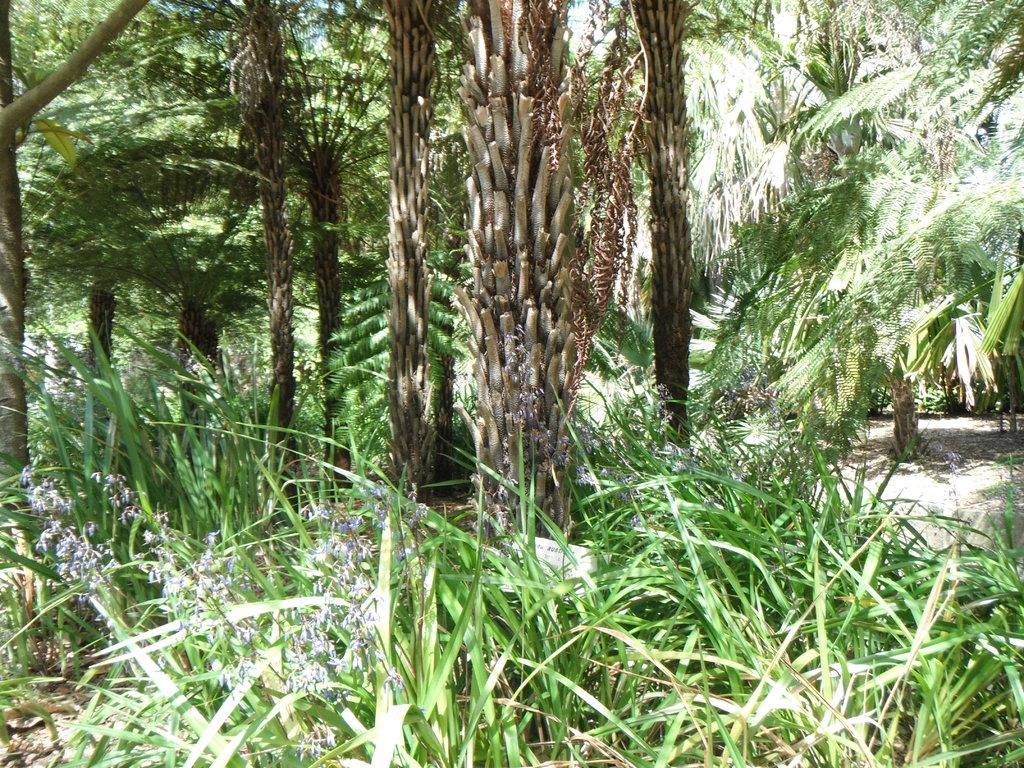Could you give a brief overview of what you see in this image? There are many plants. On the plants there are flowers. Also there are many trees. 